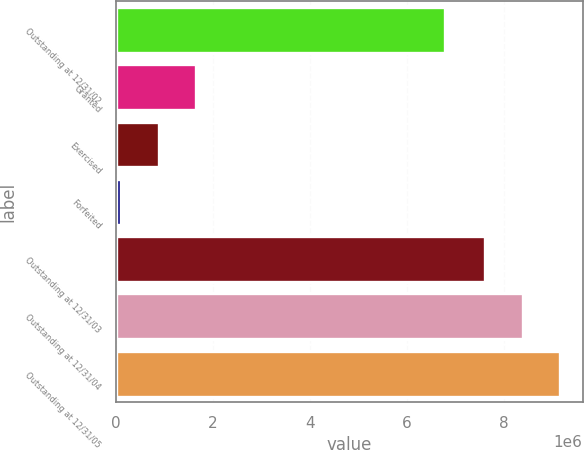Convert chart to OTSL. <chart><loc_0><loc_0><loc_500><loc_500><bar_chart><fcel>Outstanding at 12/31/02<fcel>Granted<fcel>Exercised<fcel>Forfeited<fcel>Outstanding at 12/31/03<fcel>Outstanding at 12/31/04<fcel>Outstanding at 12/31/05<nl><fcel>6.79765e+06<fcel>1.66143e+06<fcel>885715<fcel>110000<fcel>7.61718e+06<fcel>8.39289e+06<fcel>9.16861e+06<nl></chart> 